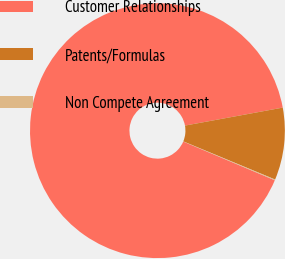Convert chart to OTSL. <chart><loc_0><loc_0><loc_500><loc_500><pie_chart><fcel>Customer Relationships<fcel>Patents/Formulas<fcel>Non Compete Agreement<nl><fcel>90.74%<fcel>9.16%<fcel>0.1%<nl></chart> 